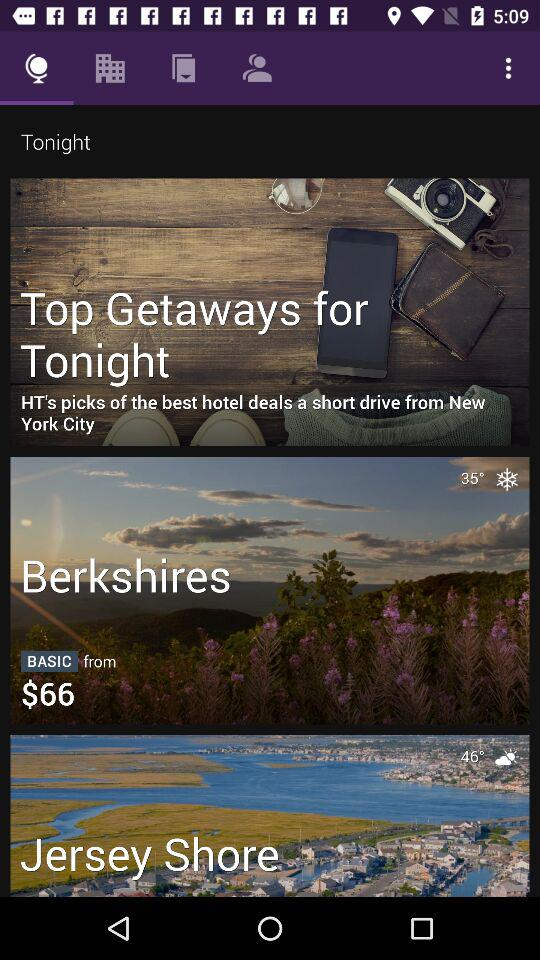How many more degrees is the temperature in Jersey Shore than in the Berkshires?
Answer the question using a single word or phrase. 11 